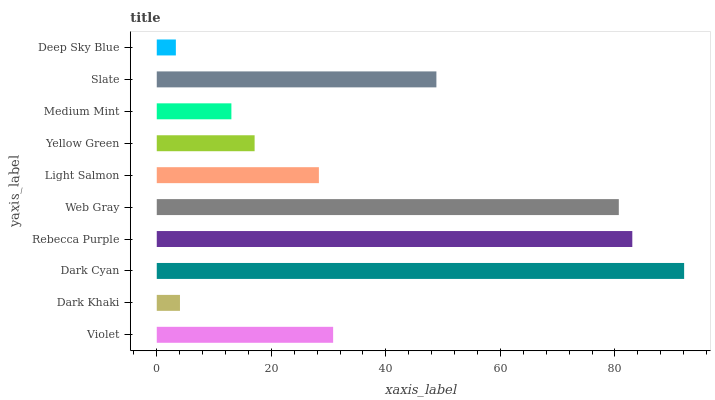Is Deep Sky Blue the minimum?
Answer yes or no. Yes. Is Dark Cyan the maximum?
Answer yes or no. Yes. Is Dark Khaki the minimum?
Answer yes or no. No. Is Dark Khaki the maximum?
Answer yes or no. No. Is Violet greater than Dark Khaki?
Answer yes or no. Yes. Is Dark Khaki less than Violet?
Answer yes or no. Yes. Is Dark Khaki greater than Violet?
Answer yes or no. No. Is Violet less than Dark Khaki?
Answer yes or no. No. Is Violet the high median?
Answer yes or no. Yes. Is Light Salmon the low median?
Answer yes or no. Yes. Is Dark Khaki the high median?
Answer yes or no. No. Is Yellow Green the low median?
Answer yes or no. No. 